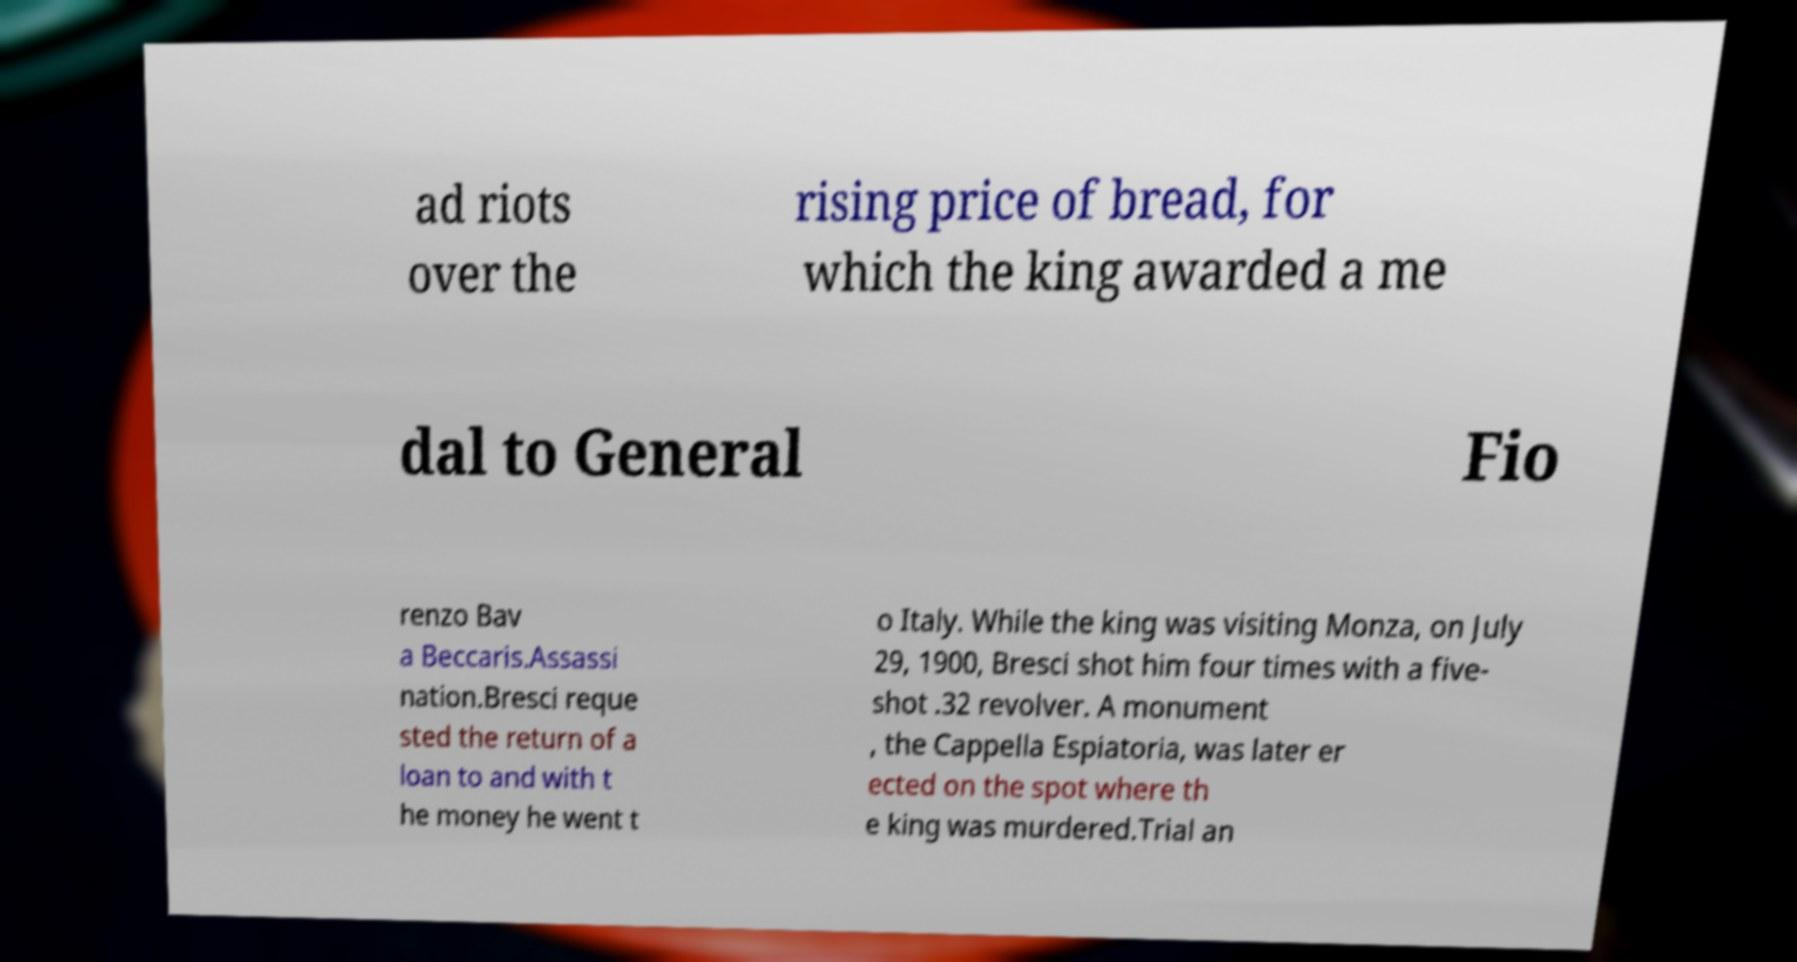Please identify and transcribe the text found in this image. ad riots over the rising price of bread, for which the king awarded a me dal to General Fio renzo Bav a Beccaris.Assassi nation.Bresci reque sted the return of a loan to and with t he money he went t o Italy. While the king was visiting Monza, on July 29, 1900, Bresci shot him four times with a five- shot .32 revolver. A monument , the Cappella Espiatoria, was later er ected on the spot where th e king was murdered.Trial an 